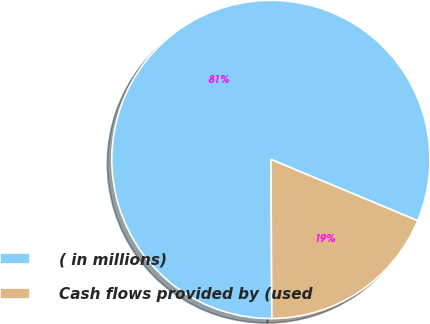Convert chart to OTSL. <chart><loc_0><loc_0><loc_500><loc_500><pie_chart><fcel>( in millions)<fcel>Cash flows provided by (used<nl><fcel>81.39%<fcel>18.61%<nl></chart> 